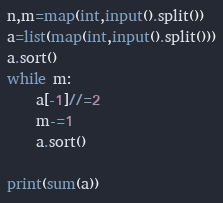Convert code to text. <code><loc_0><loc_0><loc_500><loc_500><_Python_>n,m=map(int,input().split())
a=list(map(int,input().split()))
a.sort()
while m:
    a[-1]//=2
    m-=1
    a.sort()

print(sum(a))</code> 